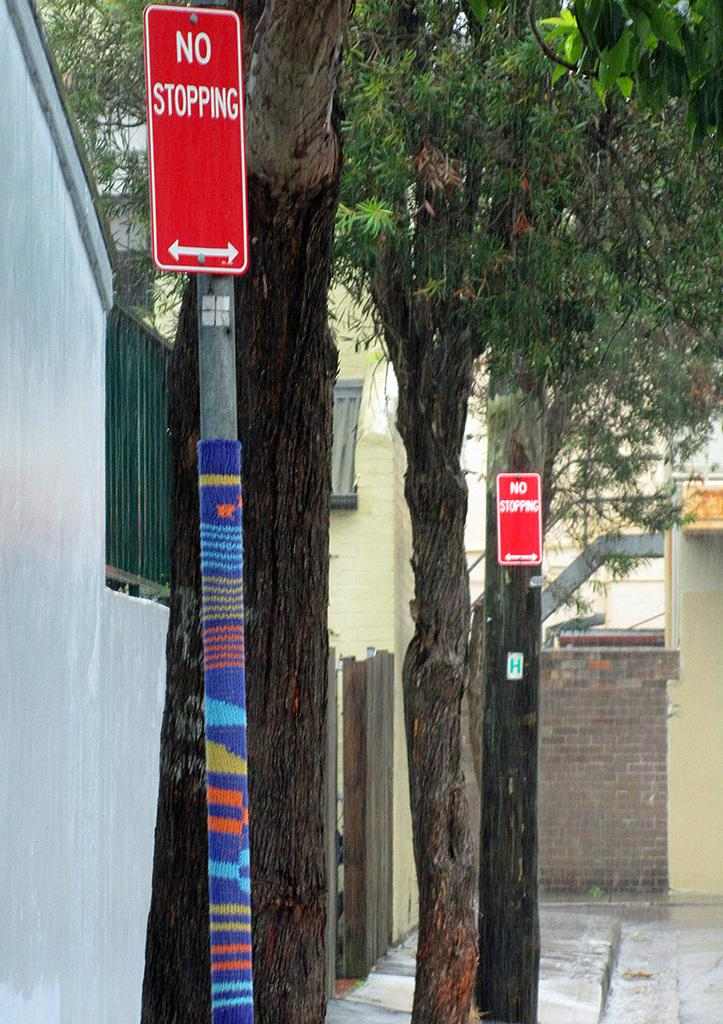What is located on the left side of the image? There is a sign board on the left side of the image. What can be seen in the middle of the image? There are trees in the middle of the image. What type of tin can be seen smashed on the ground in the image? There is no tin present in the image, nor is there any indication of something being smashed on the ground. 